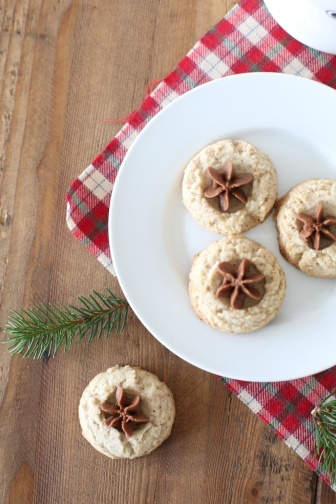How might these cookies taste and what's their possible flavor profile? The cookies, topped with star anise, suggest a flavor profile with a hint of licorice from the anise. This spice is often associated with festive recipes and could be paired with warm spices like cinnamon or cloves, providing a sweet yet slightly spicy taste, perfect for a cozy holiday treat. 